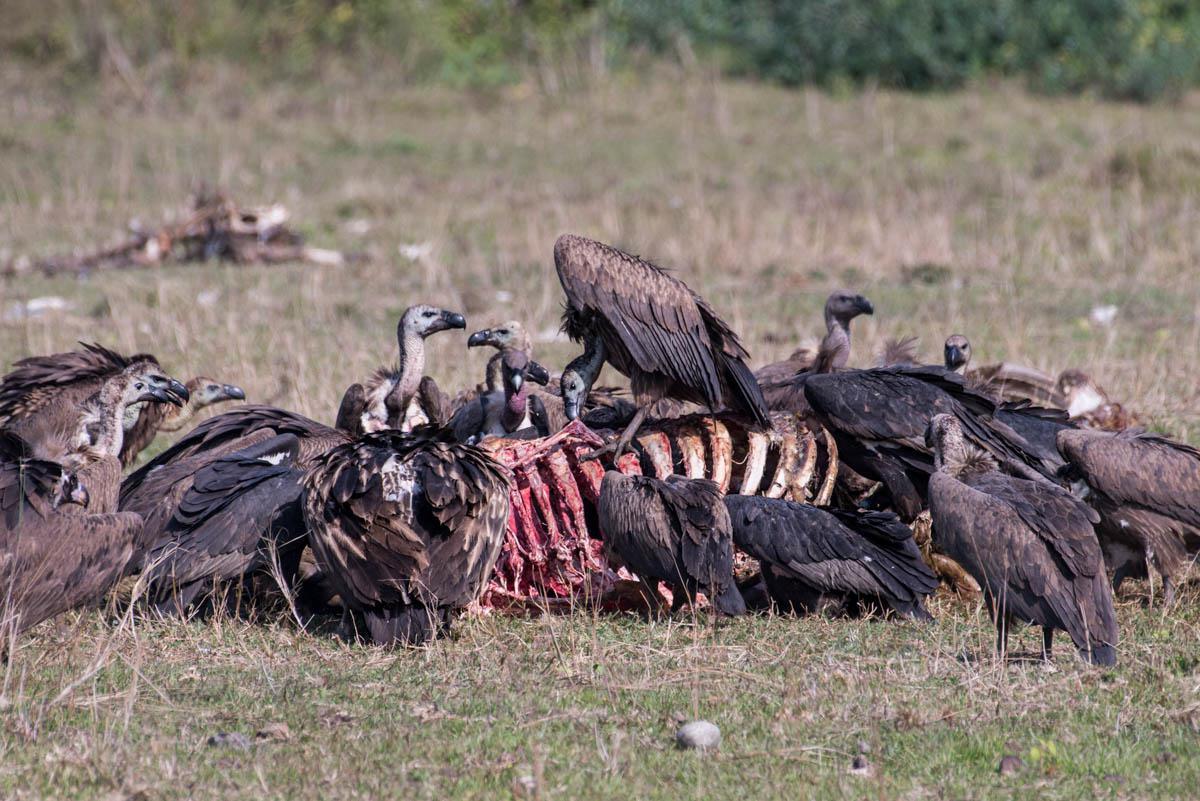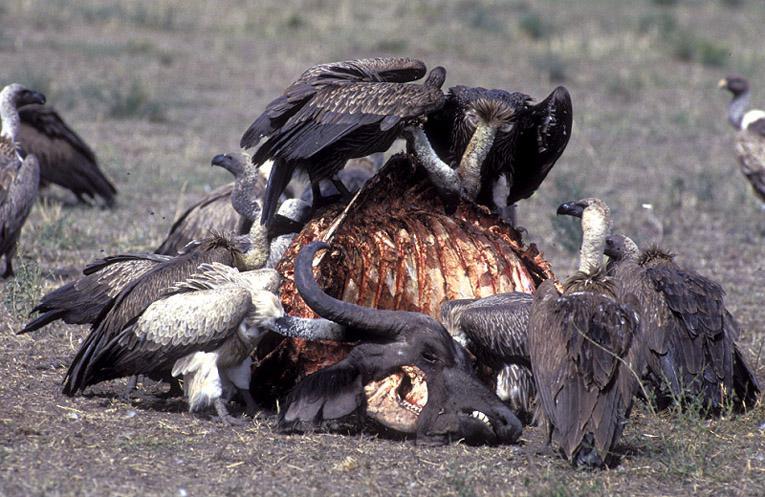The first image is the image on the left, the second image is the image on the right. Considering the images on both sides, is "One image shows a white-headed vulture in flight with its wings spread." valid? Answer yes or no. No. The first image is the image on the left, the second image is the image on the right. Considering the images on both sides, is "The left and right image contains the same vultures." valid? Answer yes or no. No. 